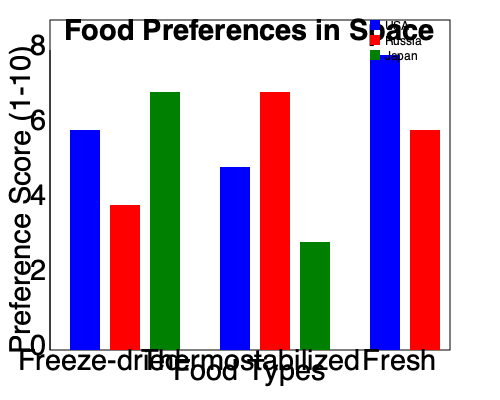Based on the bar graph showing food preferences in space for astronauts from different countries, which food type shows the greatest variation in preference scores across the three cultures represented? To determine which food type shows the greatest variation in preference scores, we need to follow these steps:

1. Identify the three food types: Freeze-dried, Thermostabilized, and Fresh.

2. For each food type, calculate the range of scores (highest minus lowest) across the three cultures:

   a. Freeze-dried:
      USA (blue): 6
      Russia (red): 4
      Japan (green): 7
      Range = 7 - 4 = 3

   b. Thermostabilized:
      USA (blue): 5
      Russia (red): 7
      Japan (green): 3
      Range = 7 - 3 = 4

   c. Fresh:
      USA (blue): 8
      Russia (red): 6
      Japan (green): Not available
      Range = 8 - 6 = 2 (Note: Japan's data is missing, which affects the calculation)

3. Compare the ranges:
   Freeze-dried: 3
   Thermostabilized: 4
   Fresh: 2 (incomplete data)

4. Identify the largest range, which represents the greatest variation in preference scores.

The food type with the greatest variation in preference scores across the three cultures is Thermostabilized, with a range of 4.
Answer: Thermostabilized 